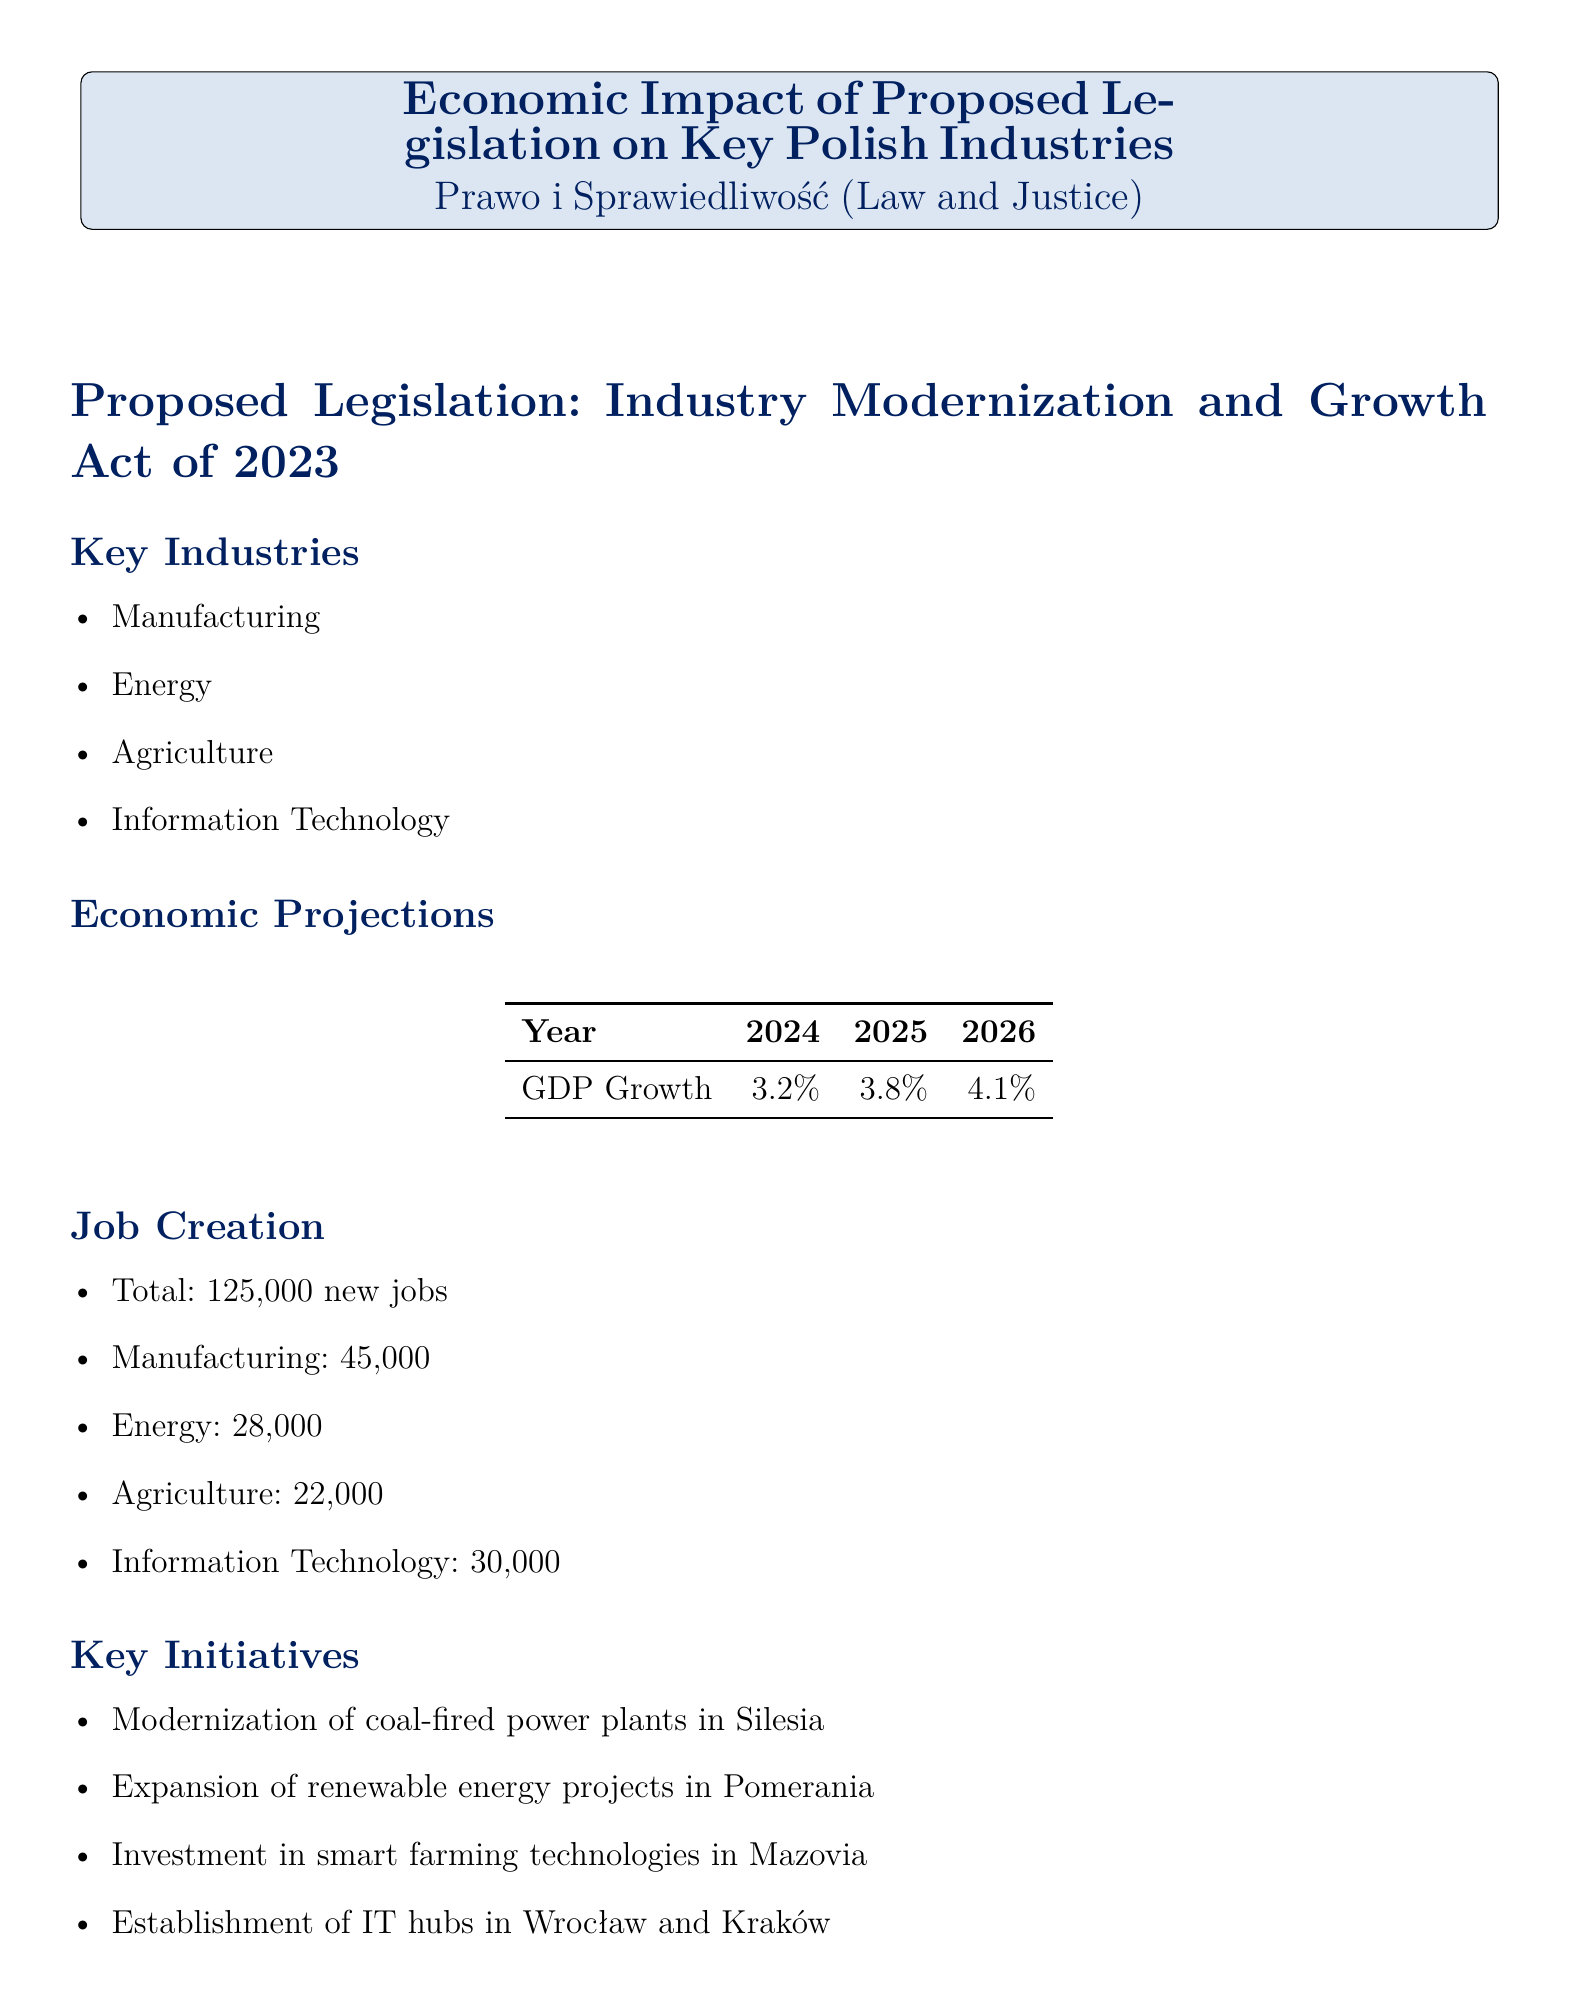What is the title of the report? The title of the report is explicitly stated at the beginning of the document.
Answer: Economic Impact of Proposed Legislation on Key Polish Industries What industries are highlighted in the report? The key industries are listed in the 'Key Industries' section of the document.
Answer: Manufacturing, Energy, Agriculture, Information Technology What is the GDP growth projection for 2025? The GDP growth is presented in the 'Economic Projections' section, specifically by year.
Answer: 3.8% How many jobs are projected to be created in the Energy sector? The job creation numbers are detailed in the 'Job Creation' section, broken down by industry.
Answer: 28,000 What is one of the economic benefits of the proposed legislation? Economic benefits are listed under the 'Economic Benefits' section of the report.
Answer: Increased exports to EU markets Which institution is supporting the proposed legislation? The supporting institutions are specified in the 'Supporting Institutions' section of the document.
Answer: National Bank of Poland What are the total projected new jobs created? The total job creation figure is presented in the 'Job Creation' section of the report.
Answer: 125,000 What challenge involves retraining? Challenges are listed in the 'Potential Challenges' section of the document.
Answer: Retraining workforce for new technologies What conclusion is drawn at the end of the report? The conclusion summarizes the intentions and expected outcomes of the legislation in the final section.
Answer: The proposed legislation is expected to significantly boost Poland's economic growth and create substantial employment opportunities across key industries 